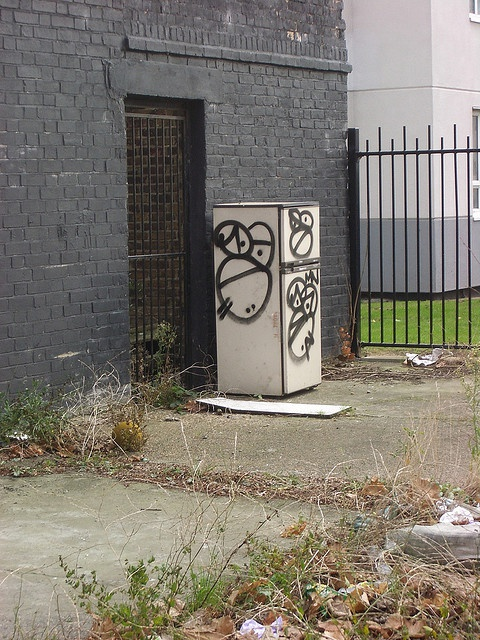Describe the objects in this image and their specific colors. I can see a refrigerator in gray, darkgray, lightgray, and black tones in this image. 